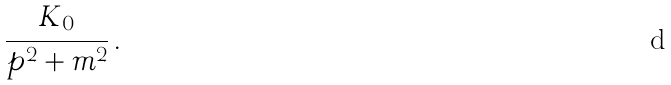<formula> <loc_0><loc_0><loc_500><loc_500>\frac { K _ { 0 } } { p ^ { 2 } + m ^ { 2 } } \, .</formula> 